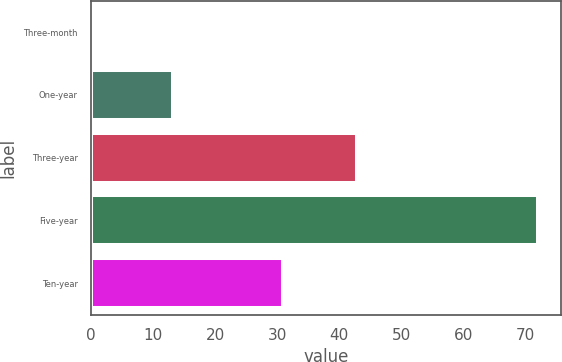<chart> <loc_0><loc_0><loc_500><loc_500><bar_chart><fcel>Three-month<fcel>One-year<fcel>Three-year<fcel>Five-year<fcel>Ten-year<nl><fcel>0.6<fcel>13.2<fcel>42.8<fcel>72.1<fcel>31<nl></chart> 